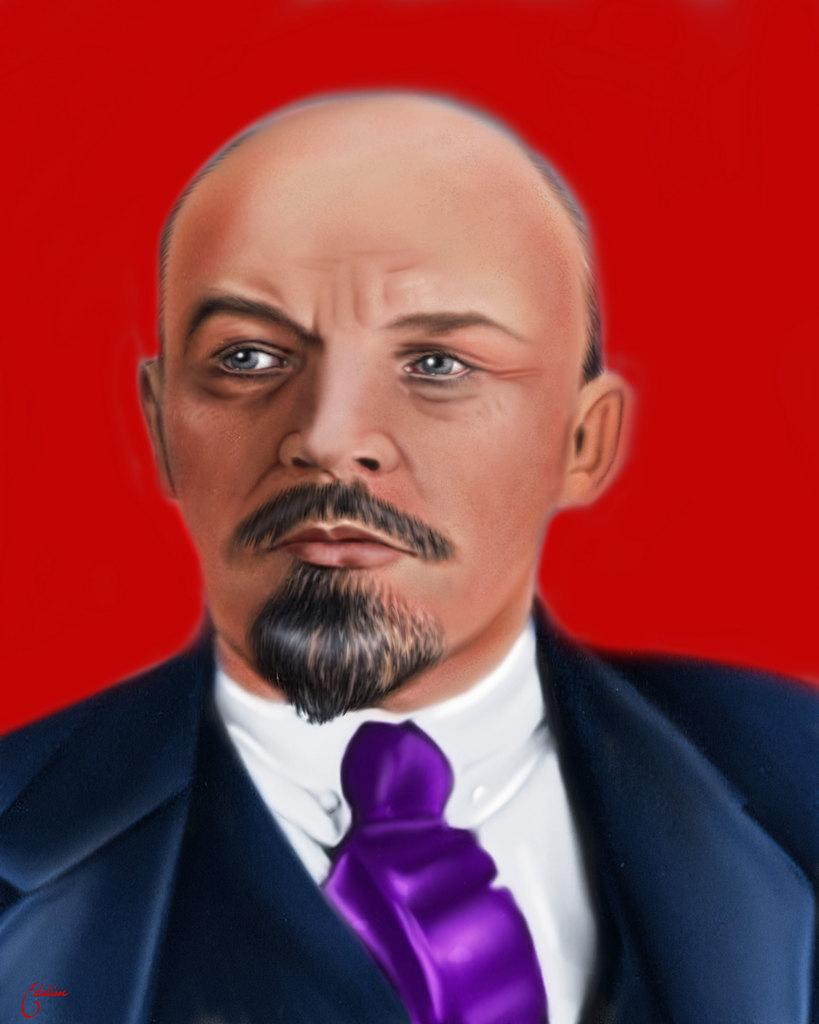Who or what is present in the image? There is a person in the image. What is the person wearing? The person is wearing a suit. What color is the background of the image? The background of the image is red. What type of shock can be seen in the image? There is no shock present in the image; it features a person wearing a suit against a red background. 